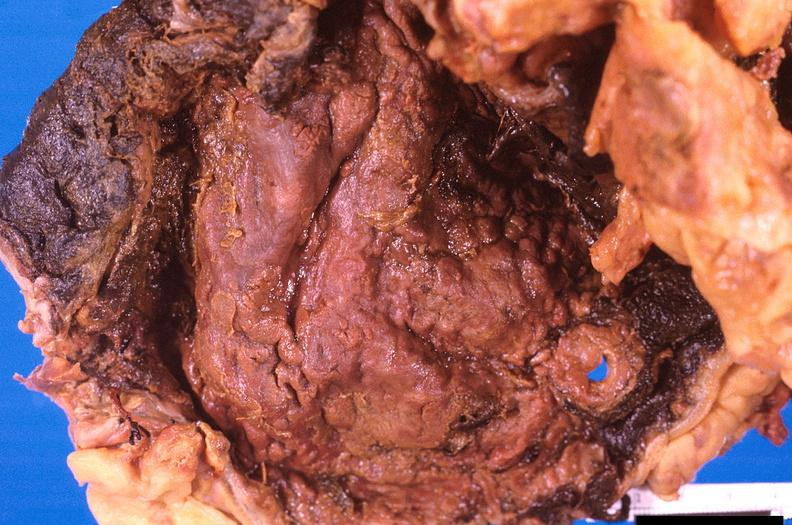what does this image show?
Answer the question using a single word or phrase. Stomach 